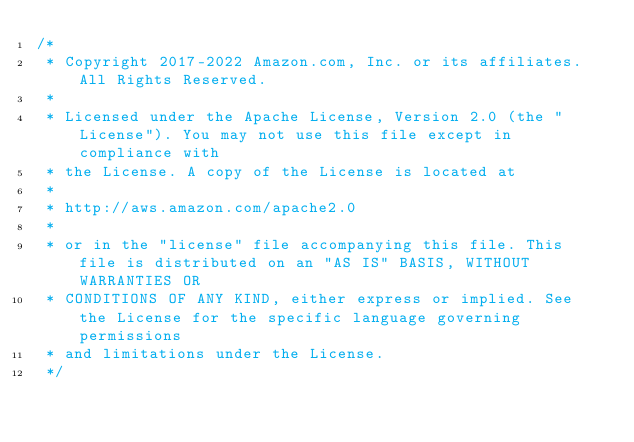Convert code to text. <code><loc_0><loc_0><loc_500><loc_500><_Java_>/*
 * Copyright 2017-2022 Amazon.com, Inc. or its affiliates. All Rights Reserved.
 * 
 * Licensed under the Apache License, Version 2.0 (the "License"). You may not use this file except in compliance with
 * the License. A copy of the License is located at
 * 
 * http://aws.amazon.com/apache2.0
 * 
 * or in the "license" file accompanying this file. This file is distributed on an "AS IS" BASIS, WITHOUT WARRANTIES OR
 * CONDITIONS OF ANY KIND, either express or implied. See the License for the specific language governing permissions
 * and limitations under the License.
 */</code> 